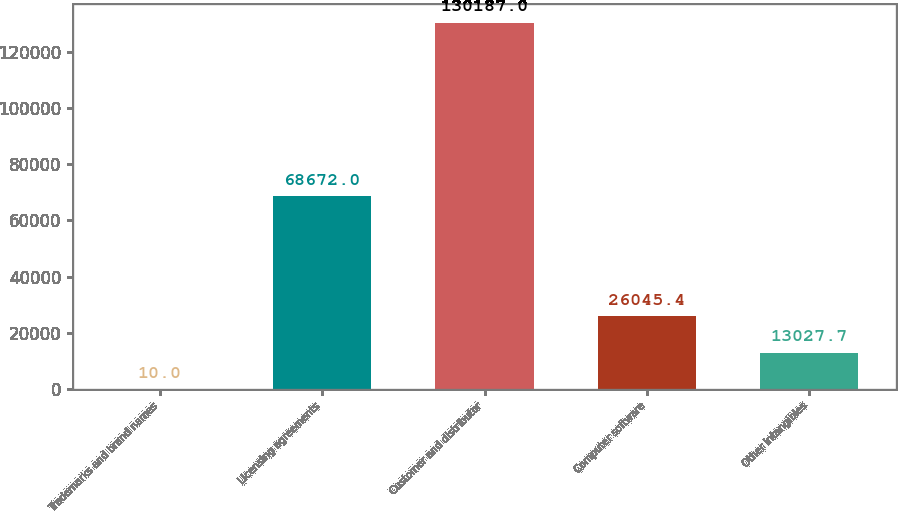Convert chart to OTSL. <chart><loc_0><loc_0><loc_500><loc_500><bar_chart><fcel>Trademarks and brand names<fcel>Licensing agreements<fcel>Customer and distributor<fcel>Computer software<fcel>Other intangibles<nl><fcel>10<fcel>68672<fcel>130187<fcel>26045.4<fcel>13027.7<nl></chart> 